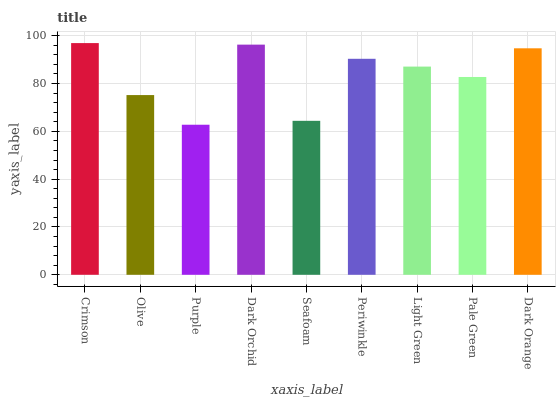Is Purple the minimum?
Answer yes or no. Yes. Is Crimson the maximum?
Answer yes or no. Yes. Is Olive the minimum?
Answer yes or no. No. Is Olive the maximum?
Answer yes or no. No. Is Crimson greater than Olive?
Answer yes or no. Yes. Is Olive less than Crimson?
Answer yes or no. Yes. Is Olive greater than Crimson?
Answer yes or no. No. Is Crimson less than Olive?
Answer yes or no. No. Is Light Green the high median?
Answer yes or no. Yes. Is Light Green the low median?
Answer yes or no. Yes. Is Seafoam the high median?
Answer yes or no. No. Is Pale Green the low median?
Answer yes or no. No. 